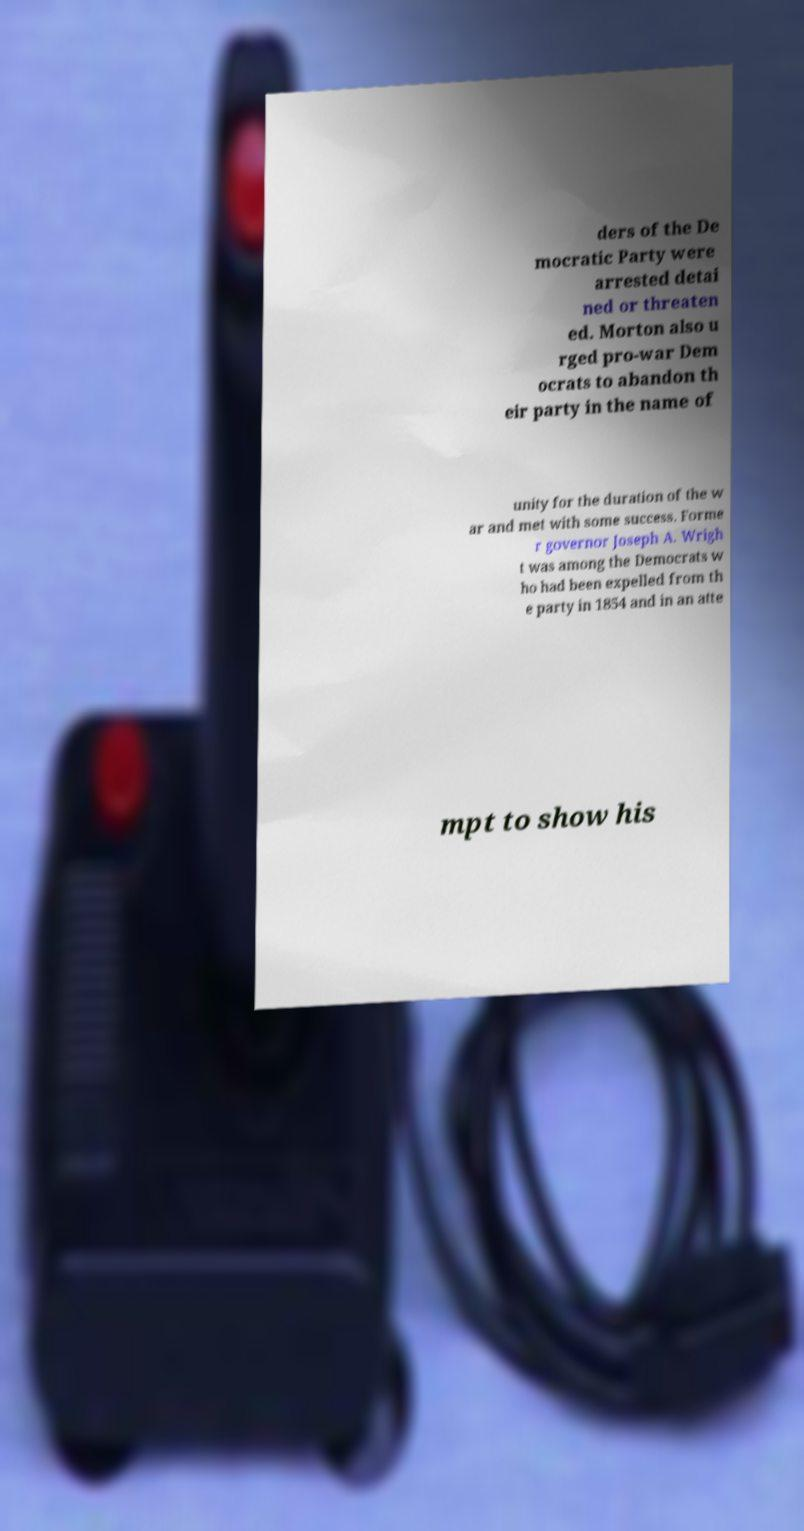Please identify and transcribe the text found in this image. ders of the De mocratic Party were arrested detai ned or threaten ed. Morton also u rged pro-war Dem ocrats to abandon th eir party in the name of unity for the duration of the w ar and met with some success. Forme r governor Joseph A. Wrigh t was among the Democrats w ho had been expelled from th e party in 1854 and in an atte mpt to show his 